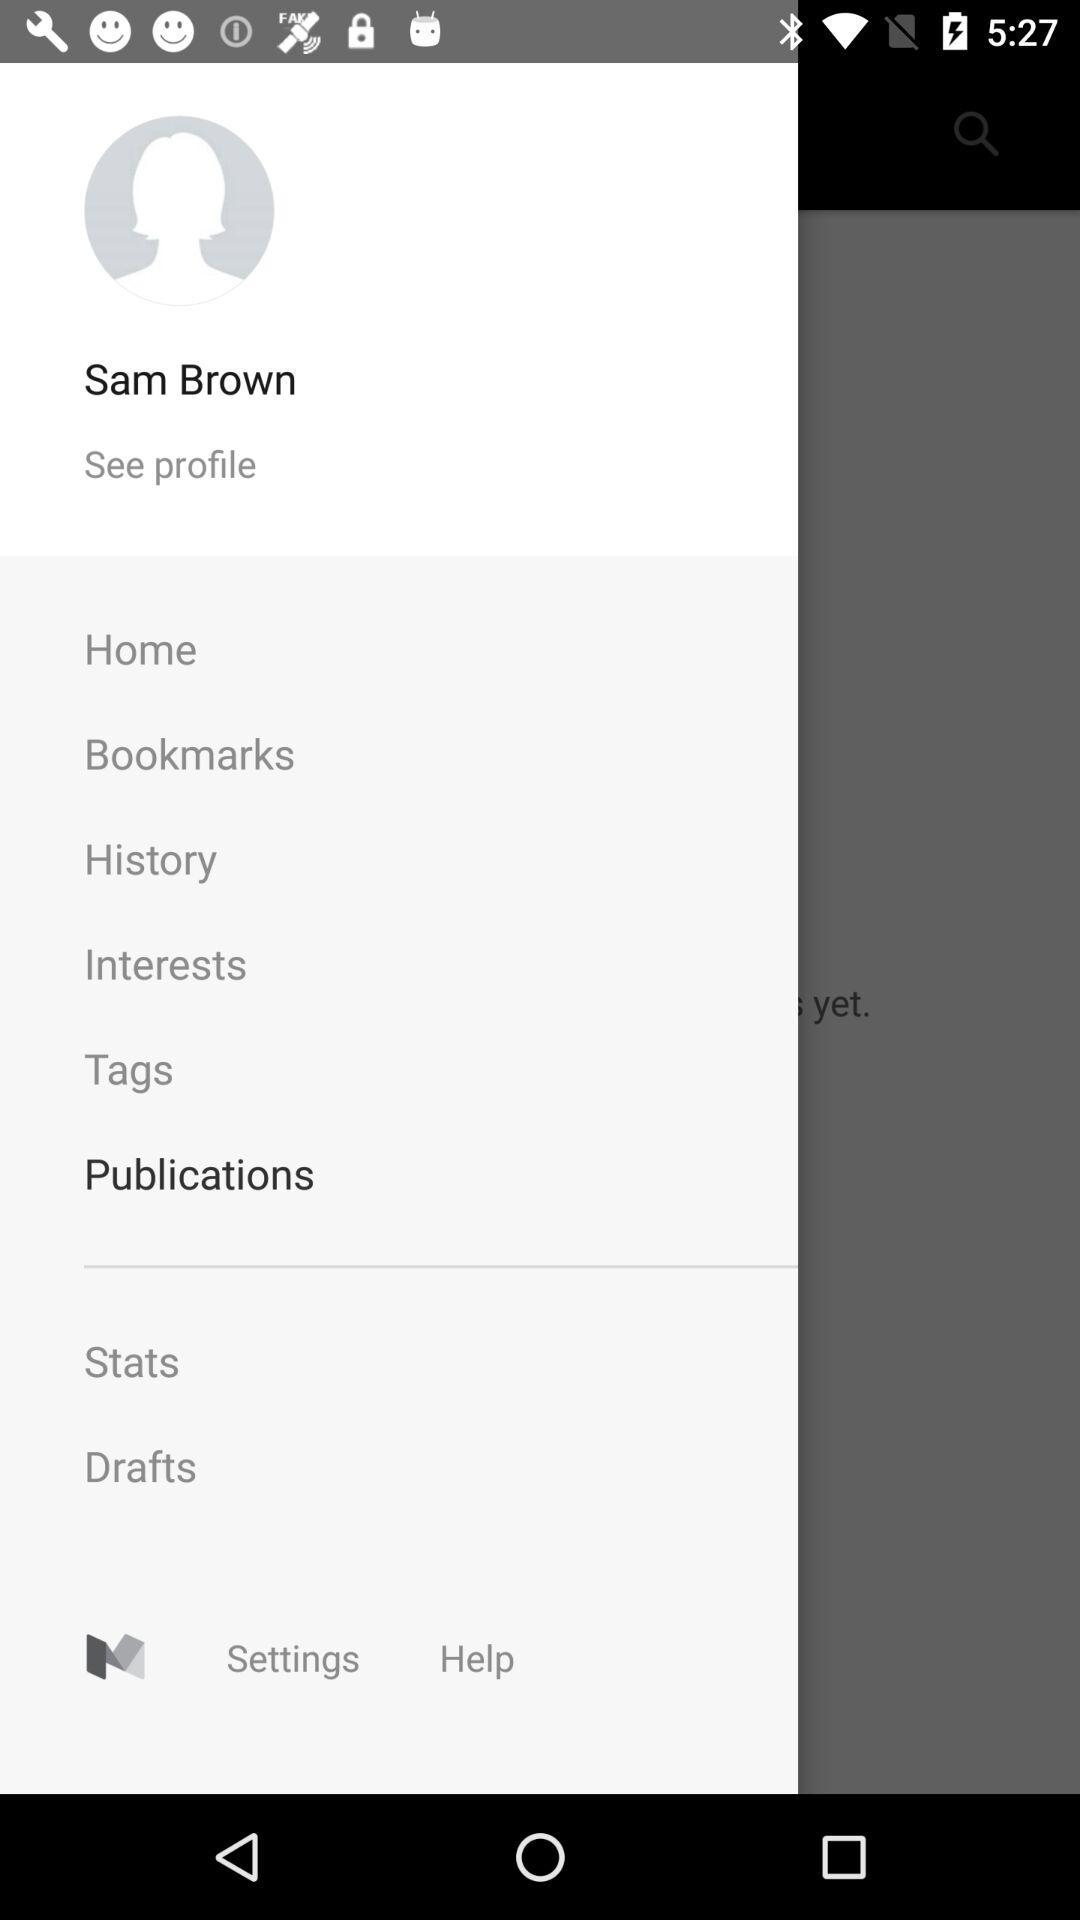What is the name of the user? The name of the user is Sam Brown. 